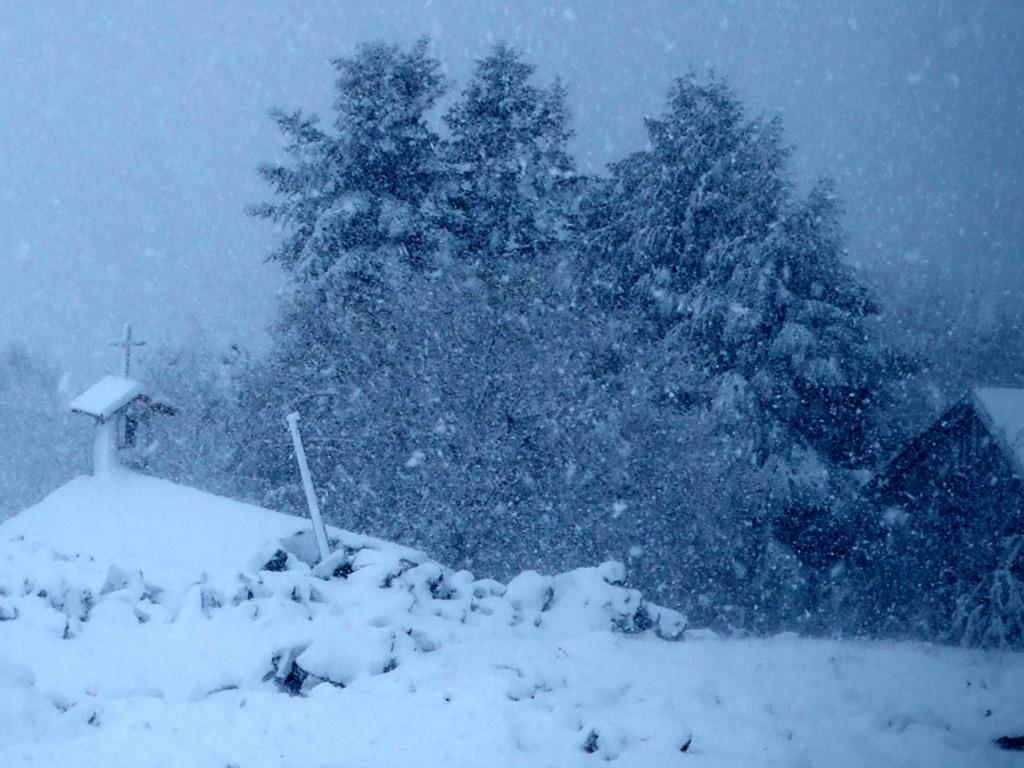What type of structure is visible in the image? There is a house in the image. What other object can be seen in the image? There is a pole in the image. What symbol is present in the image? There is a holly cross symbol in the image. What type of vegetation is visible in the image? There are trees in the image. What weather condition is depicted in the image? There is snow in the image. Can you describe the object in the image? There is an object in the image, but its specific details are not mentioned in the provided facts. What type of leather material is used to make the whip in the image? There is no whip present in the image; it is not mentioned in the provided facts. 